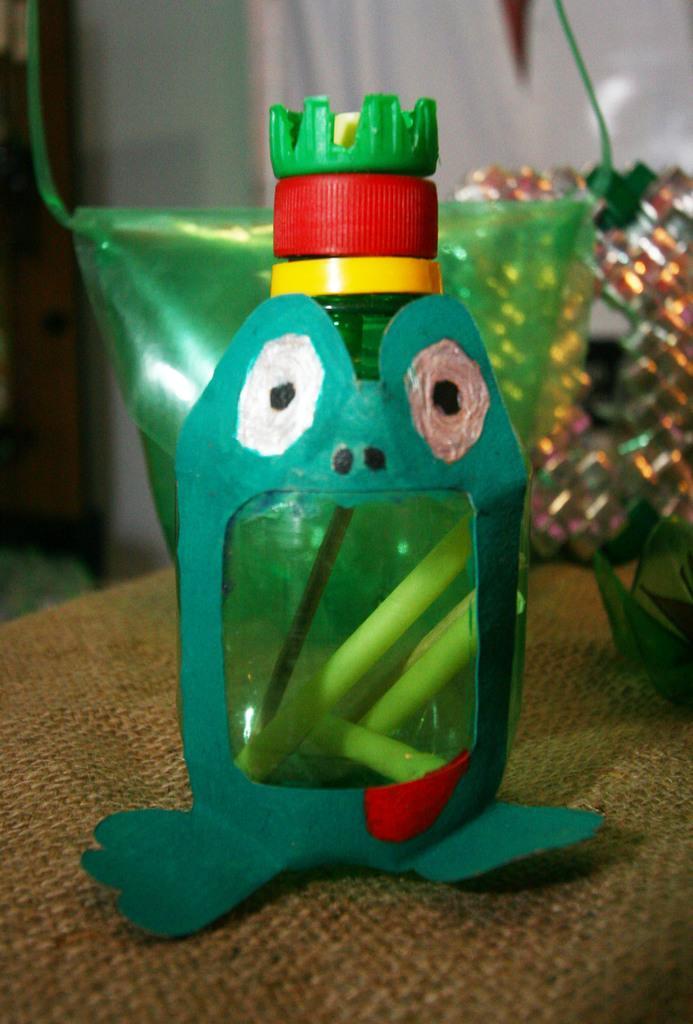Can you describe this image briefly? Here we can see a colored bottle on the table, and some other objects on it. 